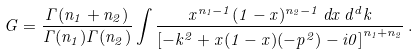Convert formula to latex. <formula><loc_0><loc_0><loc_500><loc_500>G = \frac { \Gamma ( n _ { 1 } + n _ { 2 } ) } { \Gamma ( n _ { 1 } ) \Gamma ( n _ { 2 } ) } \int \frac { x ^ { n _ { 1 } - 1 } ( 1 - x ) ^ { n _ { 2 } - 1 } \, d x \, d ^ { d } k } { \left [ - k ^ { 2 } + x ( 1 - x ) ( - p ^ { 2 } ) - i 0 \right ] ^ { n _ { 1 } + n _ { 2 } } } \, .</formula> 